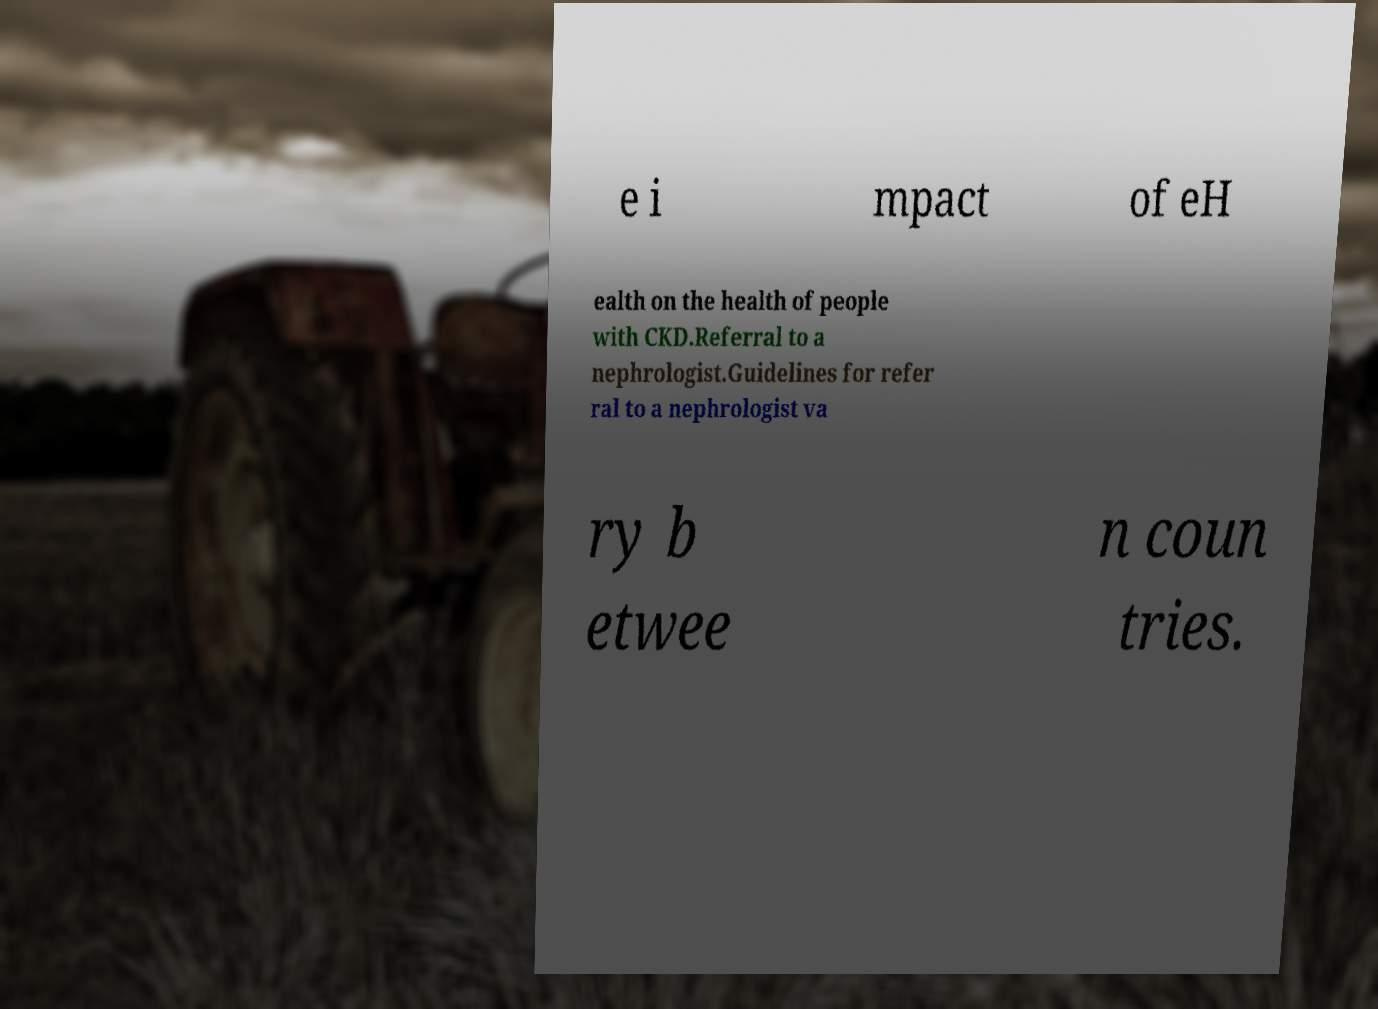Can you read and provide the text displayed in the image?This photo seems to have some interesting text. Can you extract and type it out for me? e i mpact of eH ealth on the health of people with CKD.Referral to a nephrologist.Guidelines for refer ral to a nephrologist va ry b etwee n coun tries. 